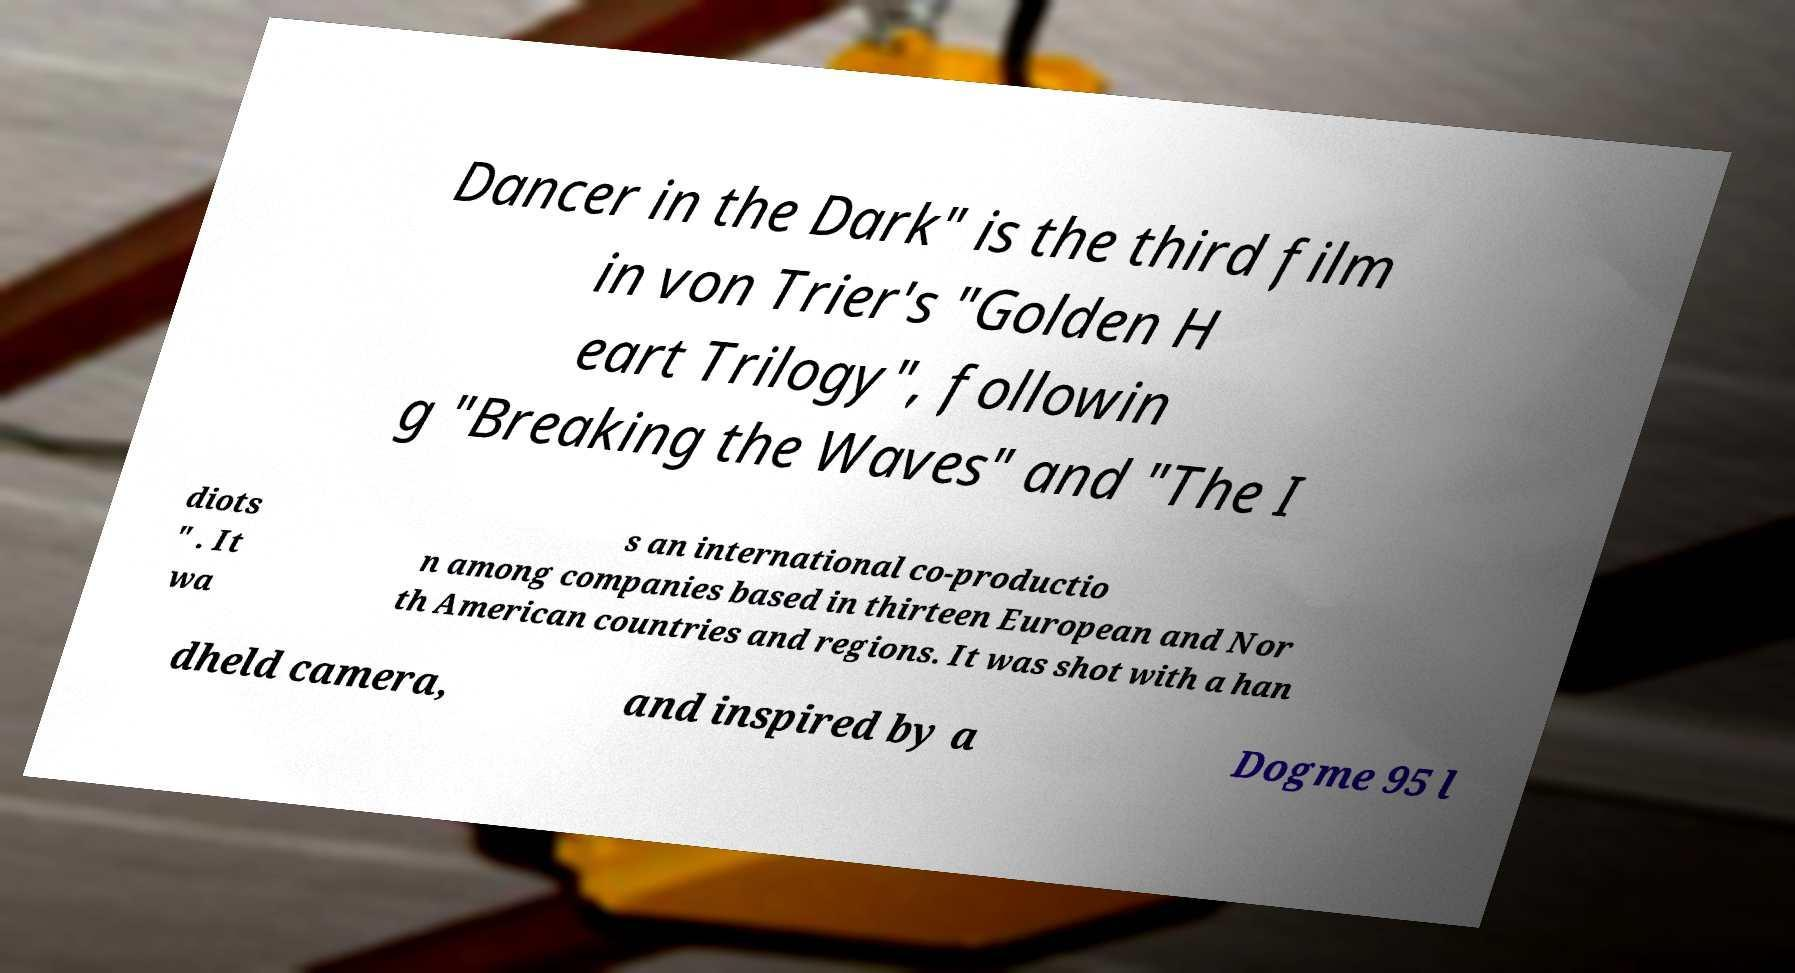There's text embedded in this image that I need extracted. Can you transcribe it verbatim? Dancer in the Dark" is the third film in von Trier's "Golden H eart Trilogy", followin g "Breaking the Waves" and "The I diots " . It wa s an international co-productio n among companies based in thirteen European and Nor th American countries and regions. It was shot with a han dheld camera, and inspired by a Dogme 95 l 